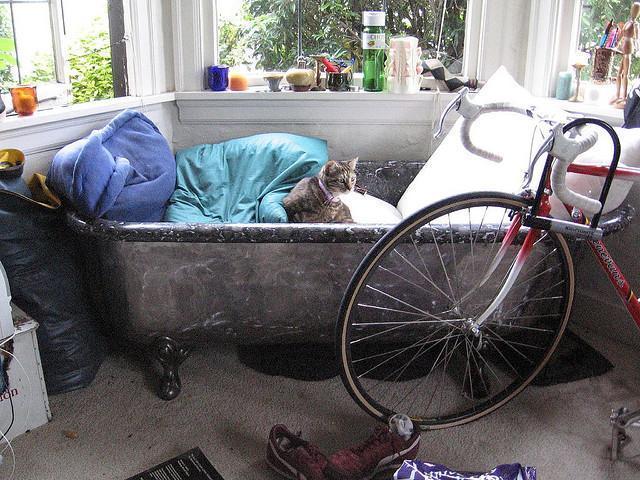How many bikes are present?
Give a very brief answer. 1. How many women are in this picture?
Give a very brief answer. 0. 